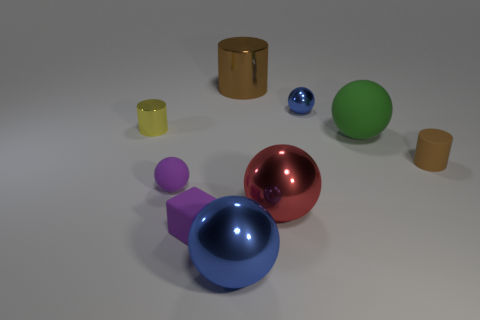What is the size of the matte thing that is the same color as the small rubber cube?
Your answer should be very brief. Small. Is there any other thing that has the same color as the rubber cylinder?
Keep it short and to the point. Yes. Does the block have the same color as the small rubber sphere?
Provide a succinct answer. Yes. There is a brown cylinder behind the metal sphere to the right of the red object; what is its material?
Your response must be concise. Metal. What is the size of the purple rubber sphere?
Offer a terse response. Small. What is the size of the red thing that is made of the same material as the yellow object?
Offer a terse response. Large. Is the size of the shiny thing that is to the left of the purple matte cube the same as the small purple matte block?
Provide a succinct answer. Yes. There is a tiny metal thing on the left side of the blue shiny sphere in front of the small shiny thing that is left of the small purple sphere; what is its shape?
Provide a succinct answer. Cylinder. How many things are yellow shiny cylinders or rubber things that are left of the red metallic object?
Provide a succinct answer. 3. There is a blue shiny ball in front of the large green object; what size is it?
Make the answer very short. Large. 